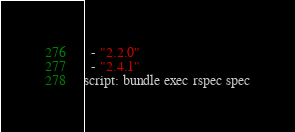<code> <loc_0><loc_0><loc_500><loc_500><_YAML_>  - "2.2.0"
  - "2.4.1"
script: bundle exec rspec spec
</code> 